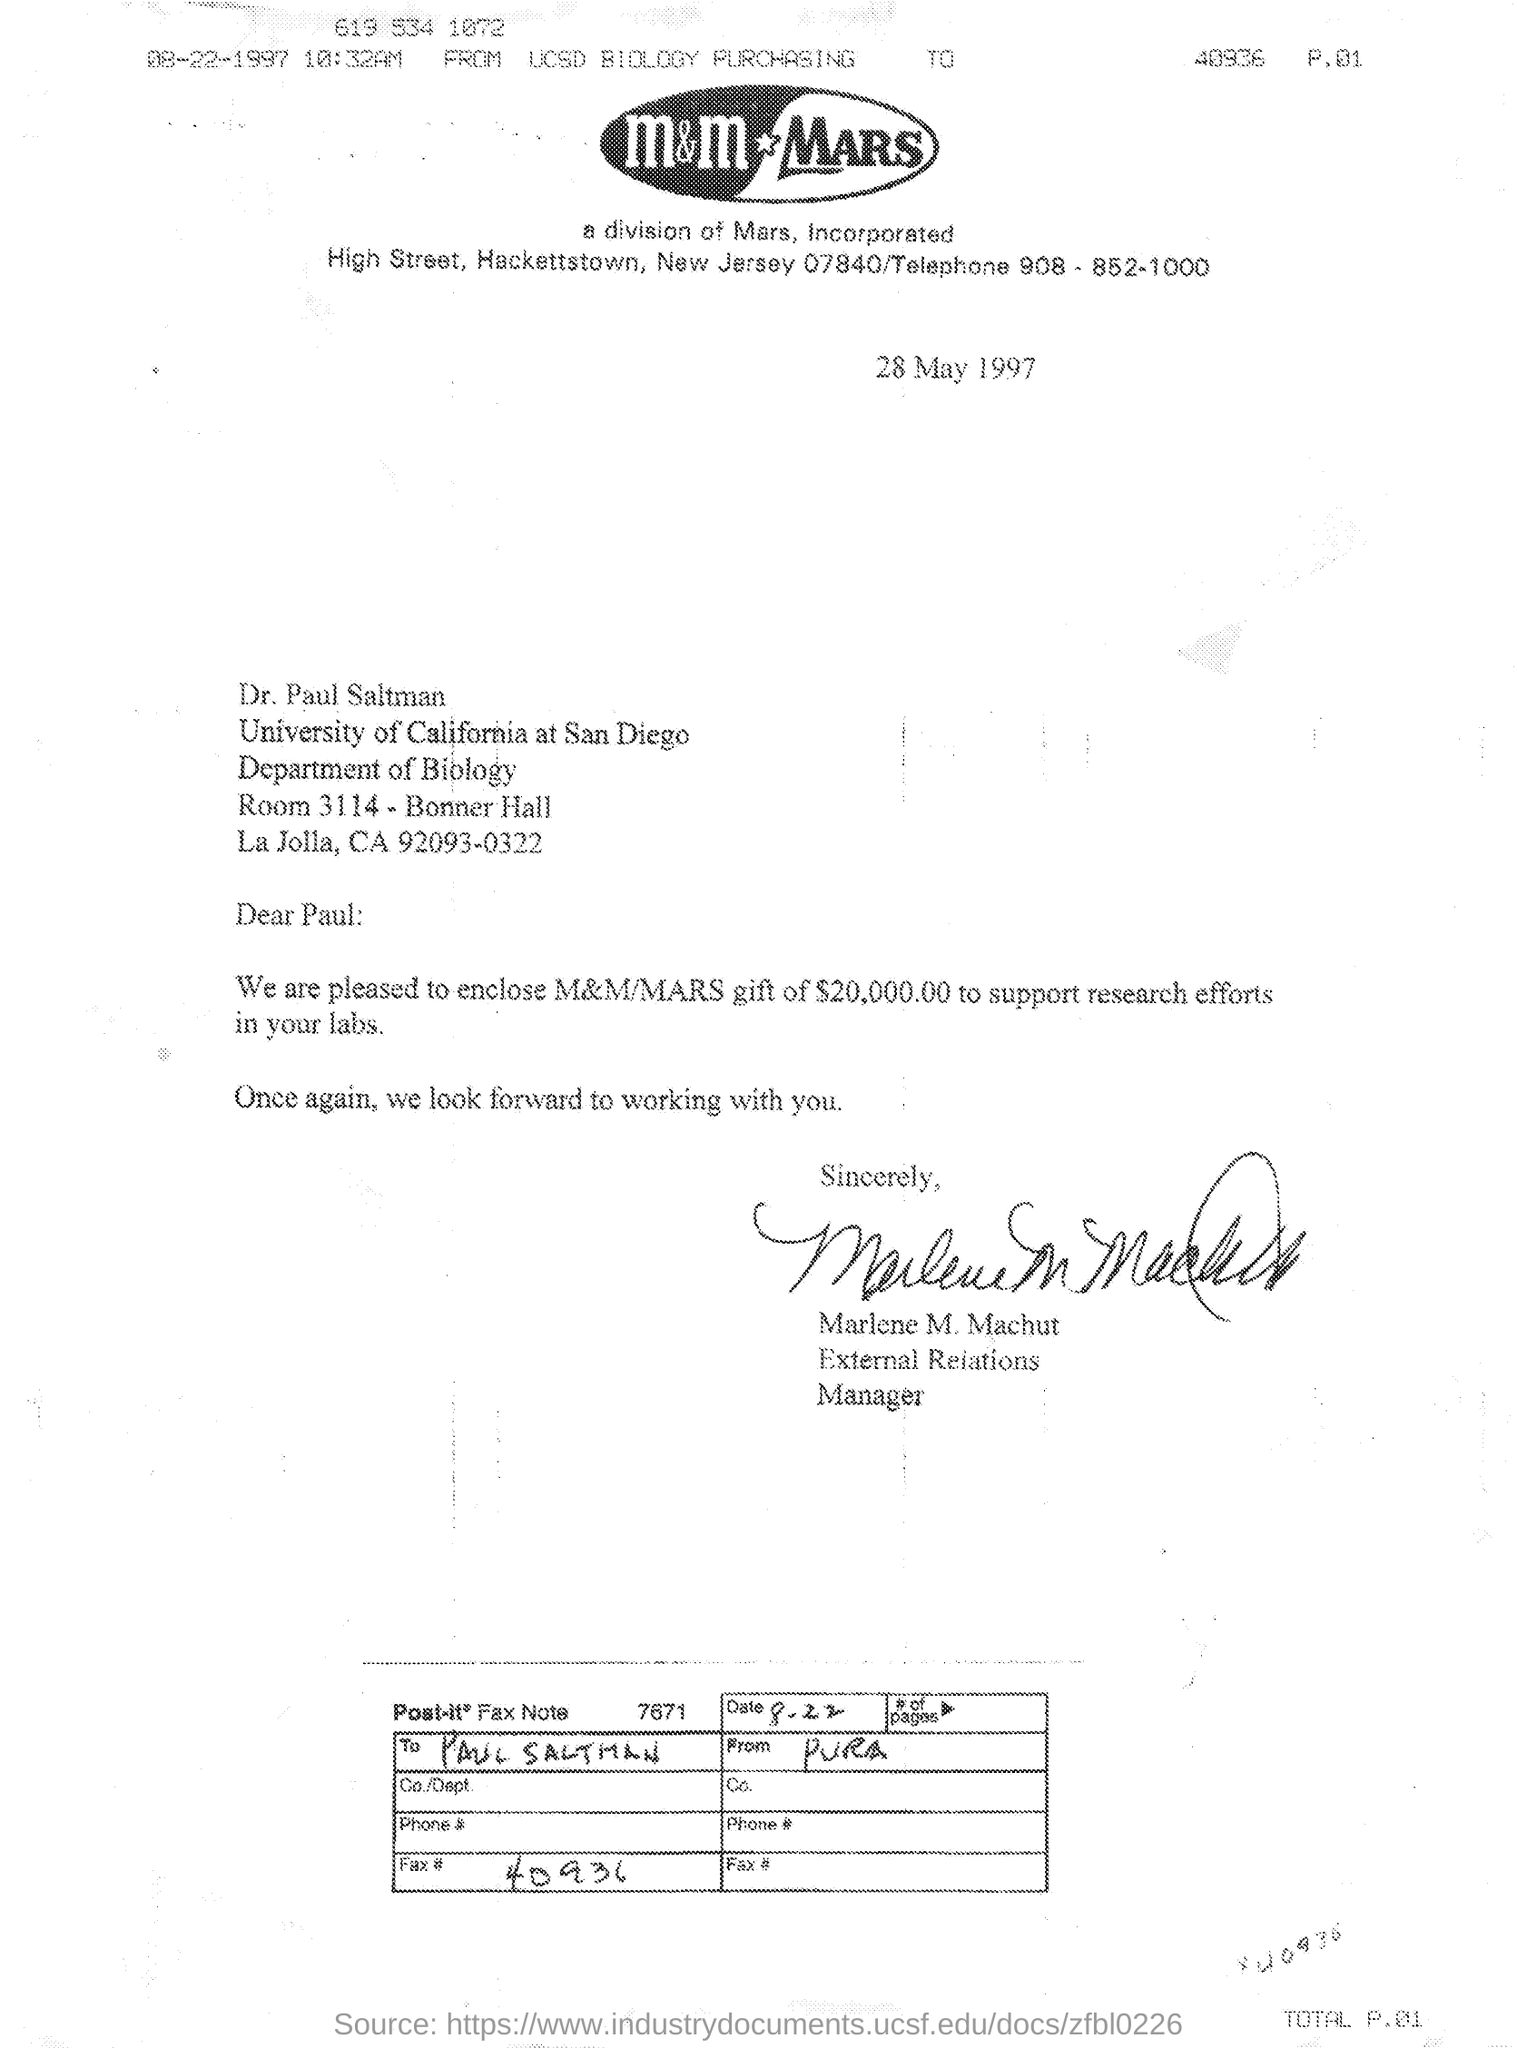Identify some key points in this picture. The date mentioned in the letter is 28 May 1997. Paul received a gift of $20,000 to support his research efforts in the laboratories. Marlene M. Machut sent the gift. 